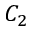Convert formula to latex. <formula><loc_0><loc_0><loc_500><loc_500>C _ { 2 }</formula> 